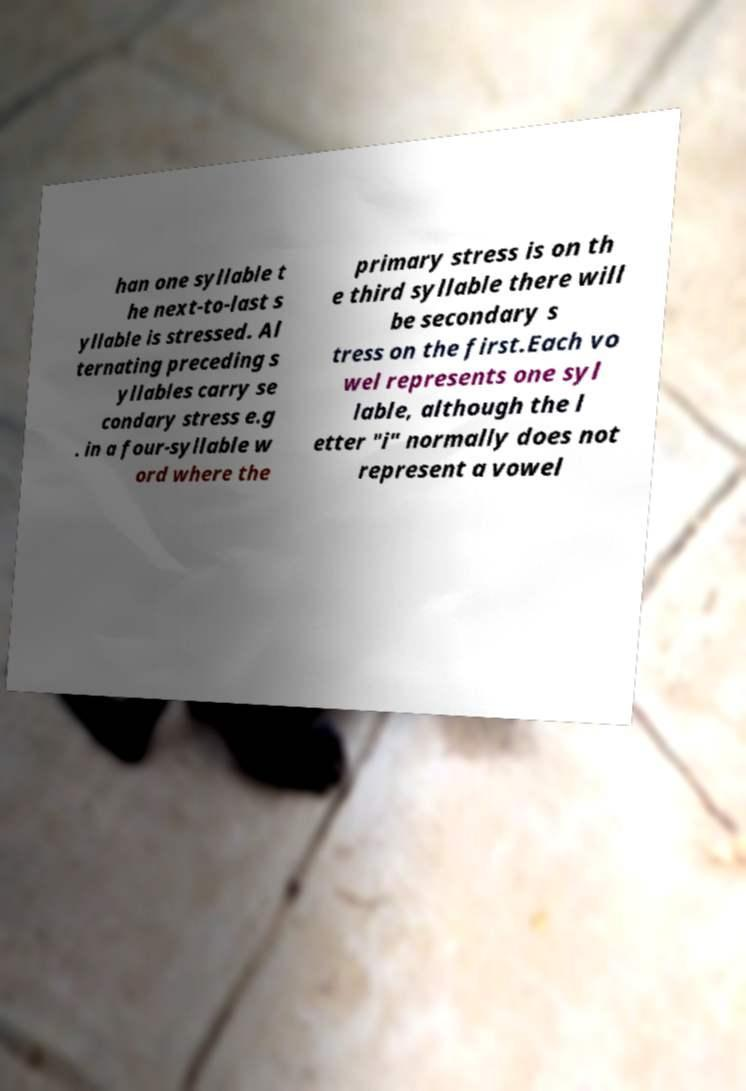For documentation purposes, I need the text within this image transcribed. Could you provide that? han one syllable t he next-to-last s yllable is stressed. Al ternating preceding s yllables carry se condary stress e.g . in a four-syllable w ord where the primary stress is on th e third syllable there will be secondary s tress on the first.Each vo wel represents one syl lable, although the l etter "i" normally does not represent a vowel 